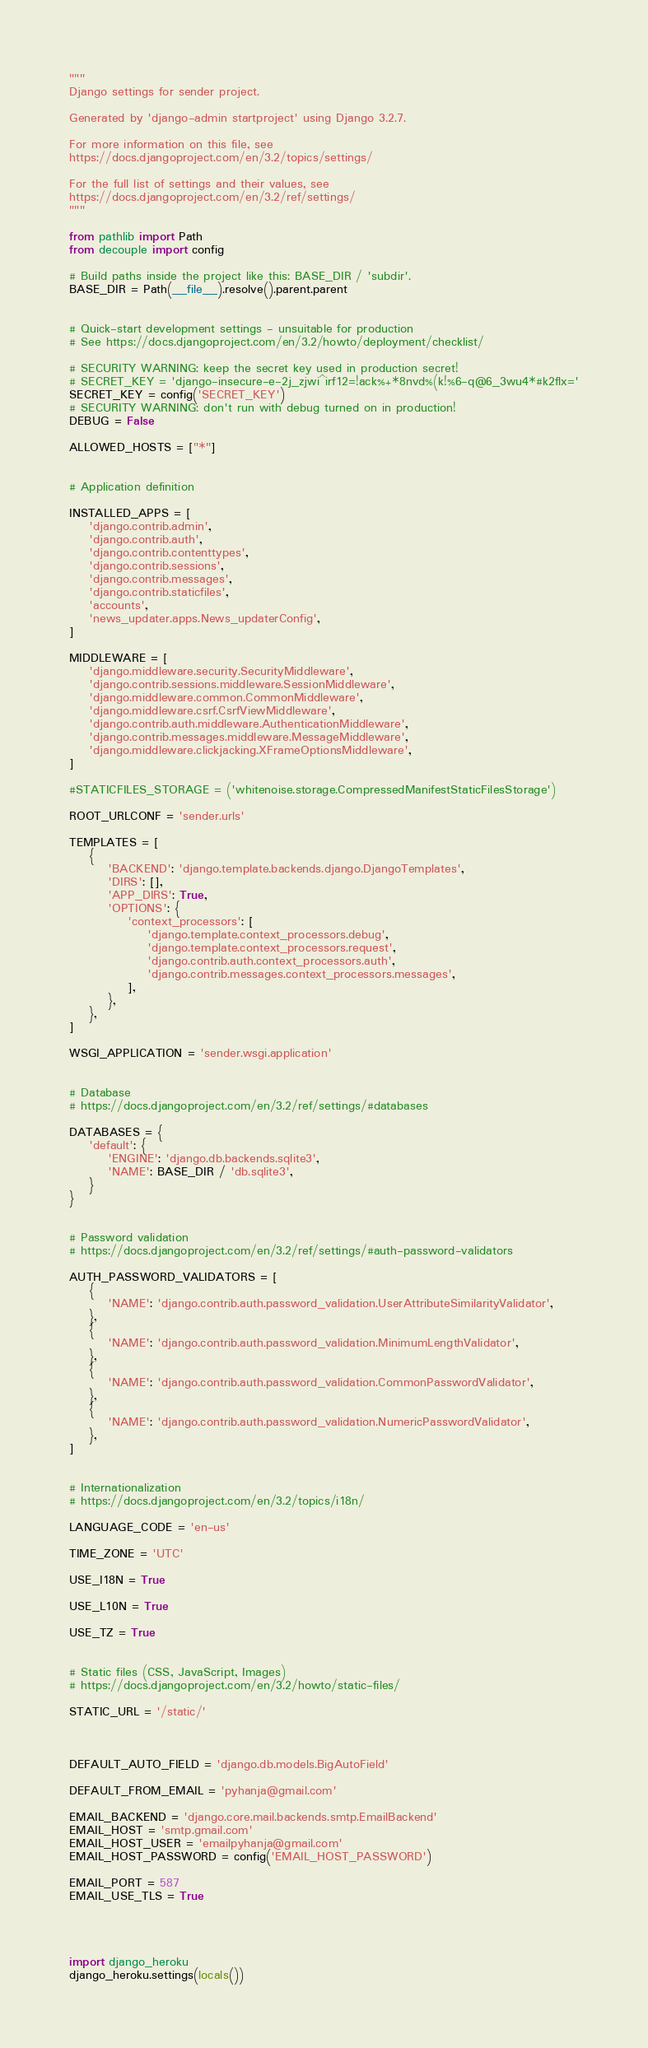Convert code to text. <code><loc_0><loc_0><loc_500><loc_500><_Python_>"""
Django settings for sender project.

Generated by 'django-admin startproject' using Django 3.2.7.

For more information on this file, see
https://docs.djangoproject.com/en/3.2/topics/settings/

For the full list of settings and their values, see
https://docs.djangoproject.com/en/3.2/ref/settings/
"""

from pathlib import Path
from decouple import config

# Build paths inside the project like this: BASE_DIR / 'subdir'.
BASE_DIR = Path(__file__).resolve().parent.parent


# Quick-start development settings - unsuitable for production
# See https://docs.djangoproject.com/en/3.2/howto/deployment/checklist/

# SECURITY WARNING: keep the secret key used in production secret!
# SECRET_KEY = 'django-insecure-e-2j_zjwi^irf12=!ack%+*8nvd%(k!%6-q@6_3wu4*#k2flx='
SECRET_KEY = config('SECRET_KEY')
# SECURITY WARNING: don't run with debug turned on in production!
DEBUG = False

ALLOWED_HOSTS = ["*"]


# Application definition

INSTALLED_APPS = [
    'django.contrib.admin',
    'django.contrib.auth',
    'django.contrib.contenttypes',
    'django.contrib.sessions',
    'django.contrib.messages',
    'django.contrib.staticfiles',
    'accounts',
    'news_updater.apps.News_updaterConfig',
]

MIDDLEWARE = [
    'django.middleware.security.SecurityMiddleware',
    'django.contrib.sessions.middleware.SessionMiddleware',
    'django.middleware.common.CommonMiddleware',
    'django.middleware.csrf.CsrfViewMiddleware',
    'django.contrib.auth.middleware.AuthenticationMiddleware',
    'django.contrib.messages.middleware.MessageMiddleware',
    'django.middleware.clickjacking.XFrameOptionsMiddleware',
]

#STATICFILES_STORAGE = ('whitenoise.storage.CompressedManifestStaticFilesStorage')

ROOT_URLCONF = 'sender.urls'

TEMPLATES = [
    {
        'BACKEND': 'django.template.backends.django.DjangoTemplates',
        'DIRS': [],
        'APP_DIRS': True,
        'OPTIONS': {
            'context_processors': [
                'django.template.context_processors.debug',
                'django.template.context_processors.request',
                'django.contrib.auth.context_processors.auth',
                'django.contrib.messages.context_processors.messages',
            ],
        },
    },
]

WSGI_APPLICATION = 'sender.wsgi.application'


# Database
# https://docs.djangoproject.com/en/3.2/ref/settings/#databases

DATABASES = {
    'default': {
        'ENGINE': 'django.db.backends.sqlite3',
        'NAME': BASE_DIR / 'db.sqlite3',
    }
}


# Password validation
# https://docs.djangoproject.com/en/3.2/ref/settings/#auth-password-validators

AUTH_PASSWORD_VALIDATORS = [
    {
        'NAME': 'django.contrib.auth.password_validation.UserAttributeSimilarityValidator',
    },
    {
        'NAME': 'django.contrib.auth.password_validation.MinimumLengthValidator',
    },
    {
        'NAME': 'django.contrib.auth.password_validation.CommonPasswordValidator',
    },
    {
        'NAME': 'django.contrib.auth.password_validation.NumericPasswordValidator',
    },
]


# Internationalization
# https://docs.djangoproject.com/en/3.2/topics/i18n/

LANGUAGE_CODE = 'en-us'

TIME_ZONE = 'UTC'

USE_I18N = True

USE_L10N = True

USE_TZ = True


# Static files (CSS, JavaScript, Images)
# https://docs.djangoproject.com/en/3.2/howto/static-files/

STATIC_URL = '/static/'



DEFAULT_AUTO_FIELD = 'django.db.models.BigAutoField'

DEFAULT_FROM_EMAIL = 'pyhanja@gmail.com'

EMAIL_BACKEND = 'django.core.mail.backends.smtp.EmailBackend'
EMAIL_HOST = 'smtp.gmail.com'
EMAIL_HOST_USER = 'emailpyhanja@gmail.com'
EMAIL_HOST_PASSWORD = config('EMAIL_HOST_PASSWORD')

EMAIL_PORT = 587
EMAIL_USE_TLS = True




import django_heroku
django_heroku.settings(locals())</code> 